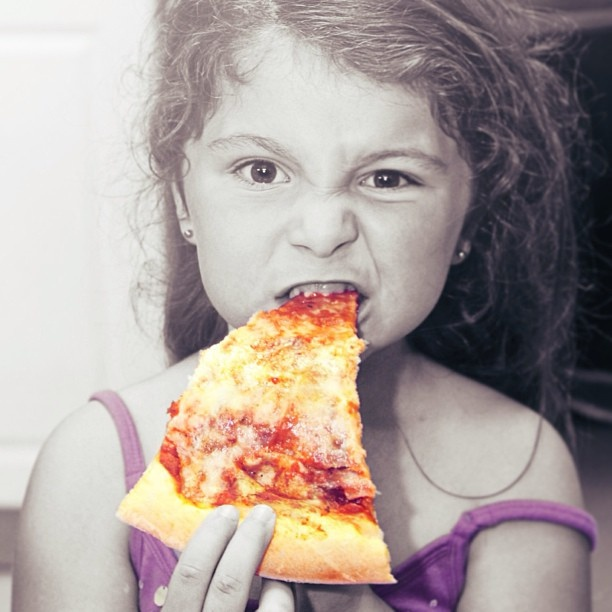Describe the objects in this image and their specific colors. I can see people in white, lightgray, darkgray, gray, and black tones and pizza in white, khaki, tan, beige, and salmon tones in this image. 